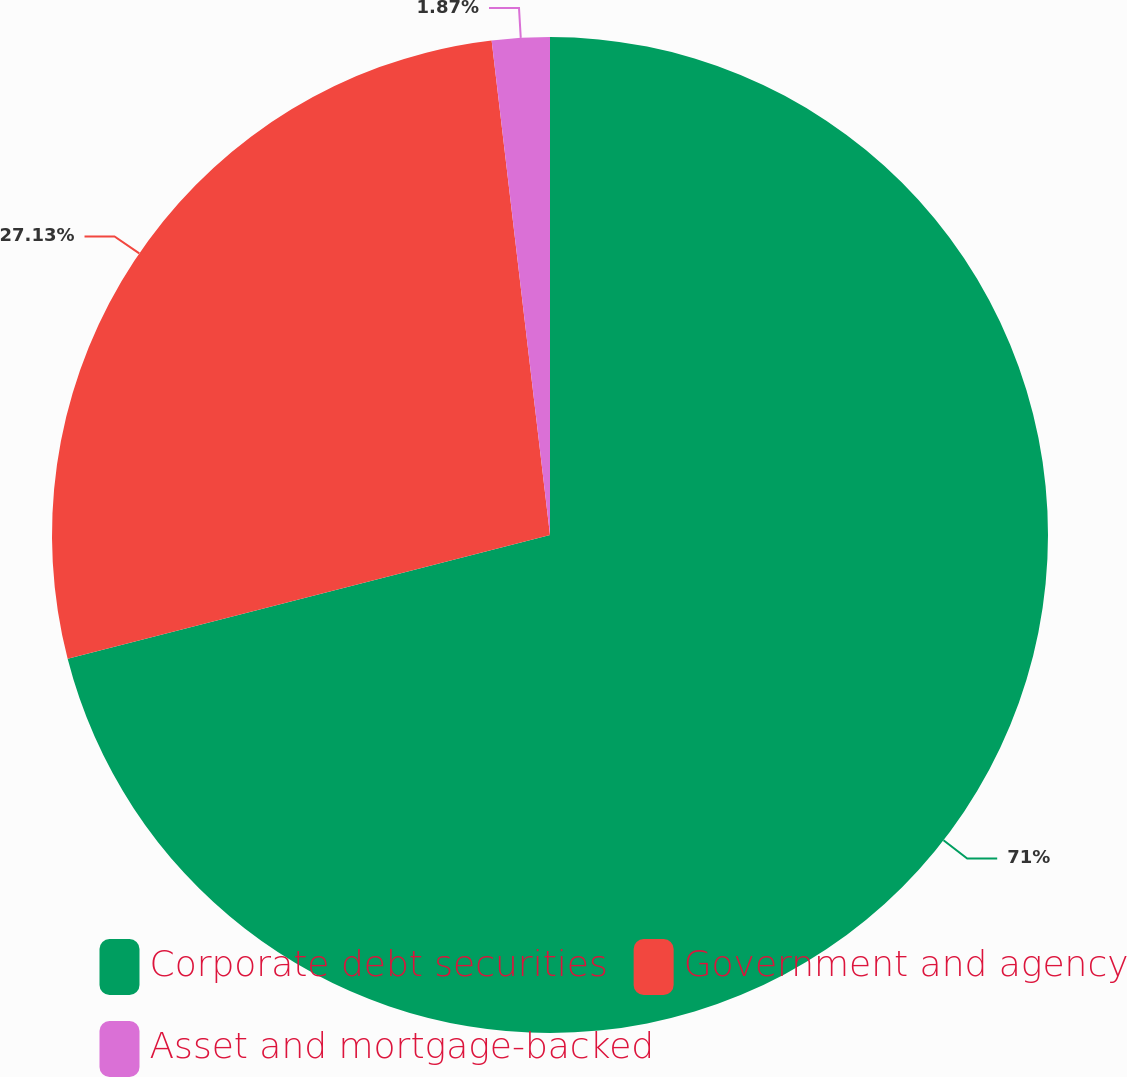Convert chart to OTSL. <chart><loc_0><loc_0><loc_500><loc_500><pie_chart><fcel>Corporate debt securities<fcel>Government and agency<fcel>Asset and mortgage-backed<nl><fcel>71.0%<fcel>27.13%<fcel>1.87%<nl></chart> 